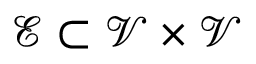Convert formula to latex. <formula><loc_0><loc_0><loc_500><loc_500>\mathcal { E } \subset \mathcal { V } \times \mathcal { V }</formula> 